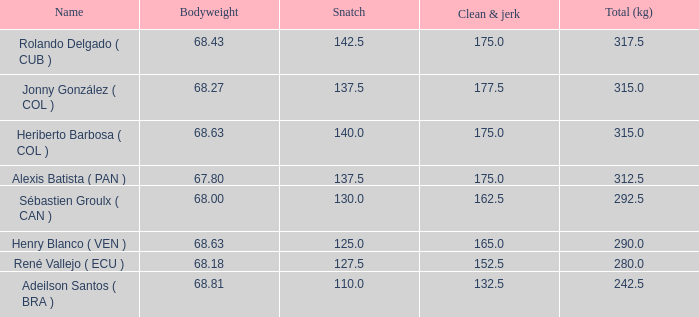6 1.0. 